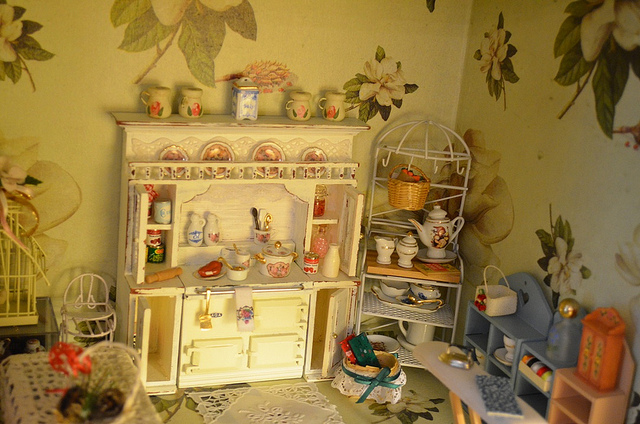What are some of the most interesting details in this miniature scene? The scene is rich with delightful details. For instance, the miniature jars on top of the cupboard, the carefully crafted food items, and the adorable cooking utensils all exhibit an impressive level of craftsmanship. There's even a small birdcage that adds a whimsical touch to the atmosphere. 